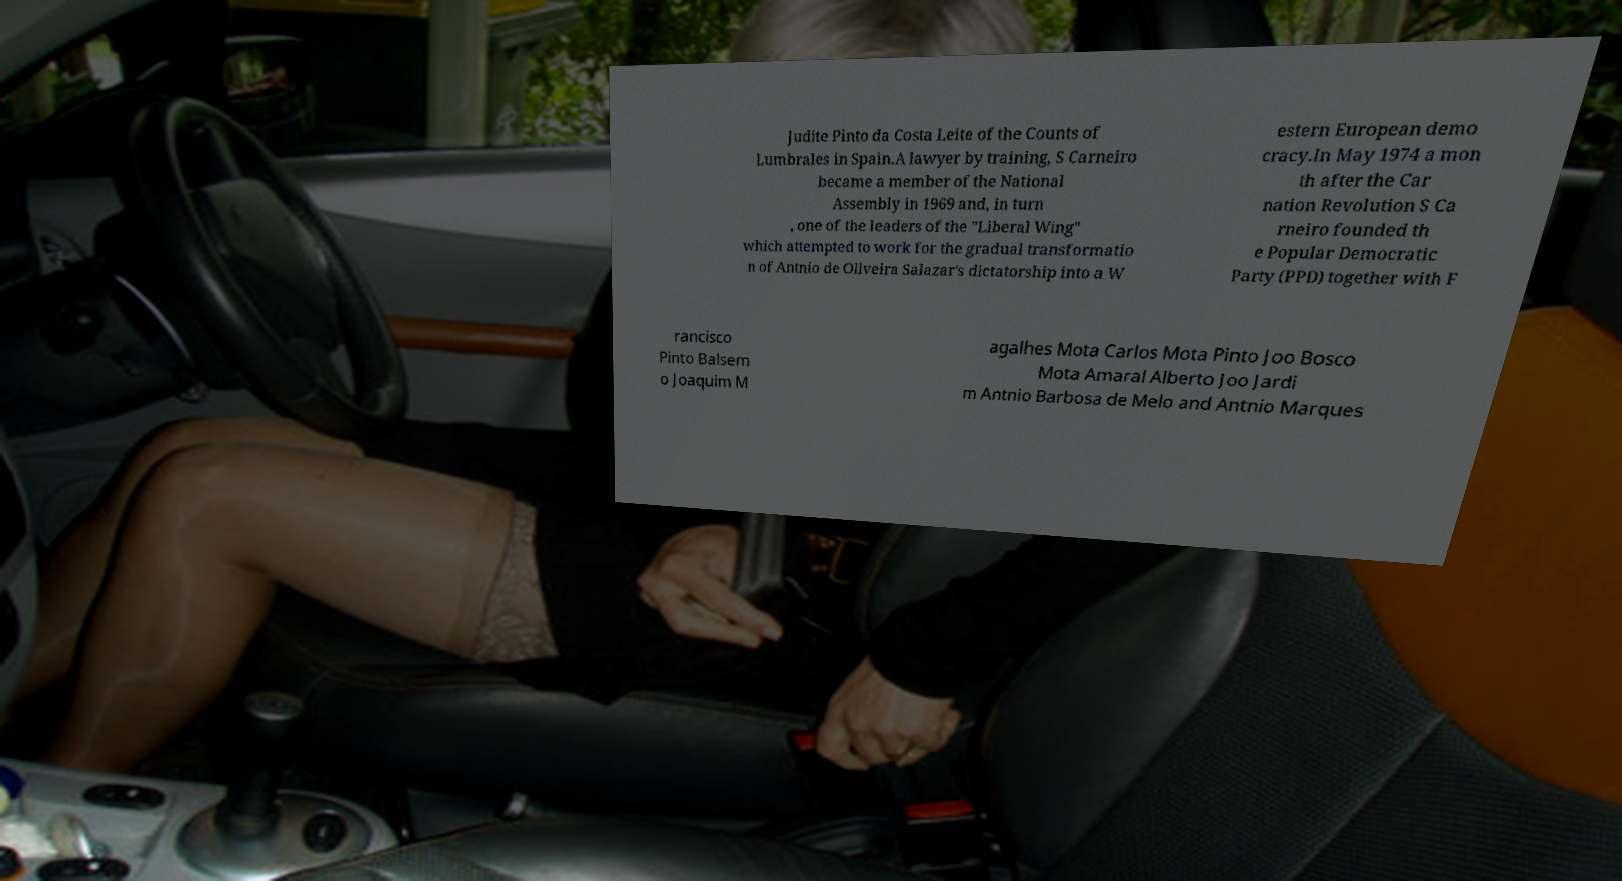There's text embedded in this image that I need extracted. Can you transcribe it verbatim? Judite Pinto da Costa Leite of the Counts of Lumbrales in Spain.A lawyer by training, S Carneiro became a member of the National Assembly in 1969 and, in turn , one of the leaders of the "Liberal Wing" which attempted to work for the gradual transformatio n of Antnio de Oliveira Salazar's dictatorship into a W estern European demo cracy.In May 1974 a mon th after the Car nation Revolution S Ca rneiro founded th e Popular Democratic Party (PPD) together with F rancisco Pinto Balsem o Joaquim M agalhes Mota Carlos Mota Pinto Joo Bosco Mota Amaral Alberto Joo Jardi m Antnio Barbosa de Melo and Antnio Marques 